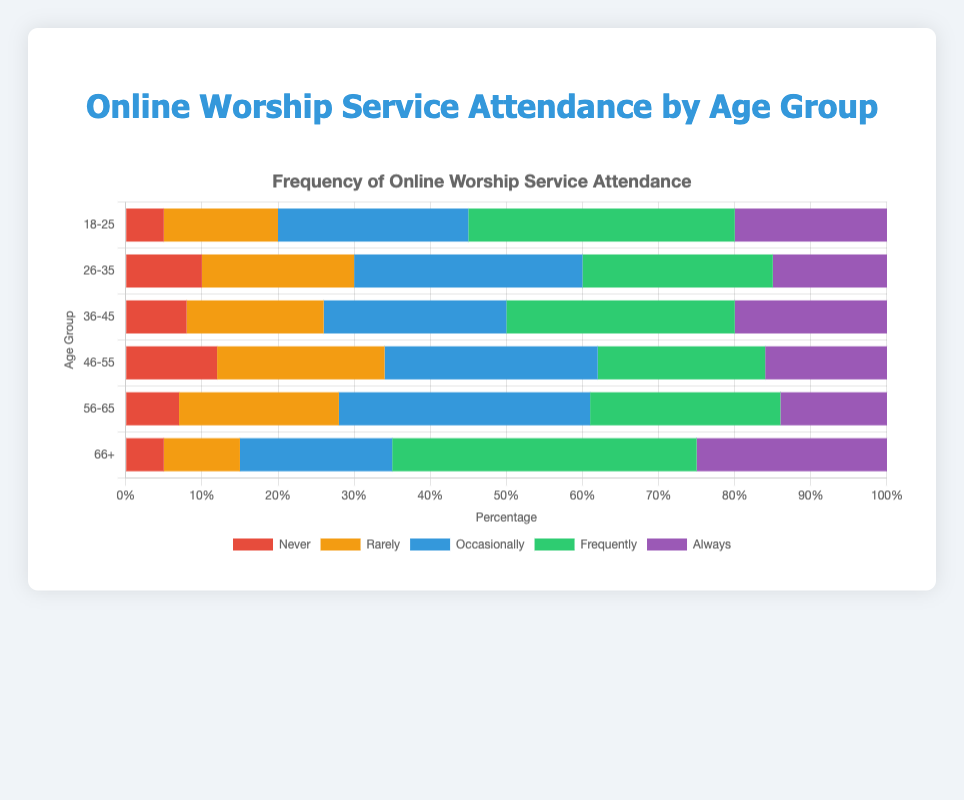Which age group has the highest percentage of people who frequently attend online worship services? To determine this, we compare the 'Frequently' attendance bars in the chart across all age groups. The age group 66+ has the longest 'Frequently' bar, indicating the highest percentage.
Answer: 66+ Which age group has more people who attend online worship services always: 18-25 or 56-65? Compare the 'Always' sections of the 18-25 and 56-65 age groups. The 18-25 age group has 20 people in the 'Always' category, while the 56-65 group has 14 people.
Answer: 18-25 What's the sum of people in the 36-45 age group who attend online worship services occasionally or frequently? Add the number of people in the 'Occasionally' and 'Frequently' categories for the 36-45 age group. There are 24 people who attend occasionally and 30 who attend frequently. Thus, 24 + 30 = 54.
Answer: 54 Which age group has the least people who rarely attend online worship services? Check the 'Rarely' bars for all age groups. The age group 66+ has the shortest 'Rarely' bar with 10 people.
Answer: 66+ What is the difference between the number of people who never attend online worship services in the 46-55 and 56-65 age groups? Subtract the number of people in the 'Never' category for the 56-65 age group from the 46-55 age group. There are 12 people who never attend in the 46-55 group and 7 in the 56-65 group. Thus, 12 - 7 = 5.
Answer: 5 In the 18-25 age group, are there more people who attend online worship services never or always? Compare the 'Never' and 'Always' bars for the 18-25 age group. There are 5 people who never attend and 20 who always attend. Since 20 > 5, more people always attend.
Answer: Always Which age group sees the highest percentage of people attending online worship services occasionally? Look at the 'Occasionally' bars for each age group. The 56-65 age group has the longest 'Occasionally' bar with 33 people.
Answer: 56-65 